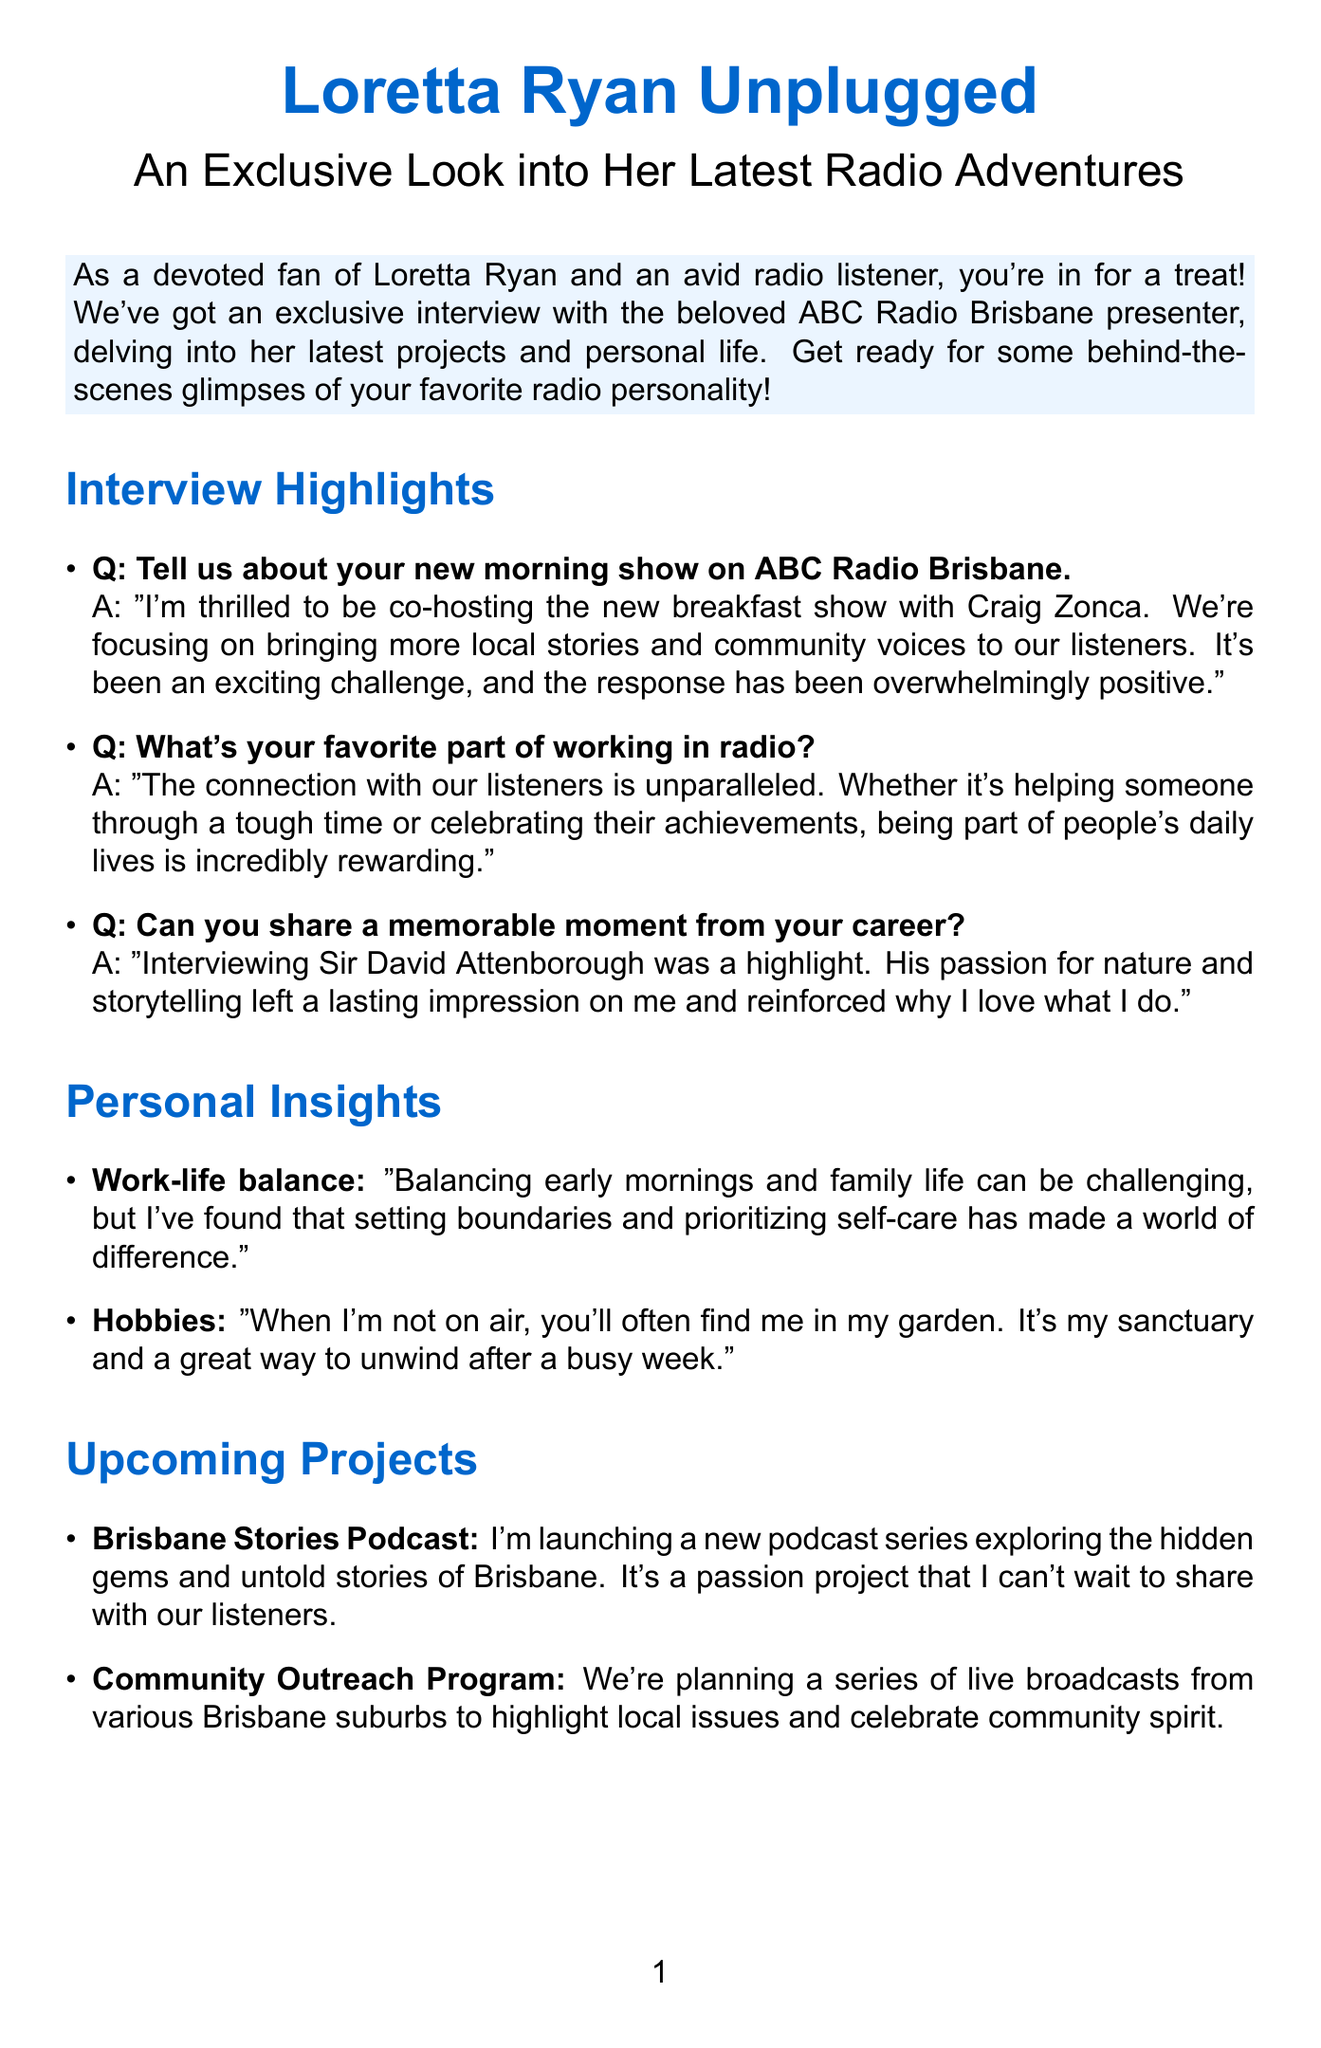What is the title of the newsletter? The title of the newsletter is provided at the beginning of the document and is clearly stated as "Loretta Ryan Unplugged: An Exclusive Look into Her Latest Radio Adventures."
Answer: Loretta Ryan Unplugged: An Exclusive Look into Her Latest Radio Adventures Who is Loretta co-hosting with on her new morning show? The document states that Loretta is co-hosting the new breakfast show with Craig Zonca, which is mentioned in the interview highlights.
Answer: Craig Zonca What is the focus of Loretta's new morning show? The document mentions that the new morning show focuses on bringing more local stories and community voices to listeners.
Answer: Local stories and community voices When is the listener meet-and-greet event? The date for the special listener meet-and-greet is explicitly provided in the document as Saturday, June 15th.
Answer: June 15th What is the name of Loretta's new podcast? The document lists the new podcast series as "Brisbane Stories Podcast," which is part of her upcoming projects.
Answer: Brisbane Stories Podcast What is a memorable moment shared by Loretta in her career? The document highlights that interviewing Sir David Attenborough was a memorable moment for Loretta, as stated in the interview.
Answer: Interviewing Sir David Attenborough What hobby does Loretta enjoy outside of radio? The personal insights section of the document mentions that Loretta enjoys gardening as a hobby when she is not on air.
Answer: Gardening What is the caption of the photo showing Loretta in her home office? The document provides the caption for the photo of Loretta's home office setup, describing it as a colorful and cozy space where she records for the podcast.
Answer: A peek into my home studio where I sometimes record for the podcast What type of program is Loretta planning for Brisbane suburbs? The upcoming projects section mentions planning a community outreach program that includes live broadcasts from various Brisbane suburbs.
Answer: Community Outreach Program 